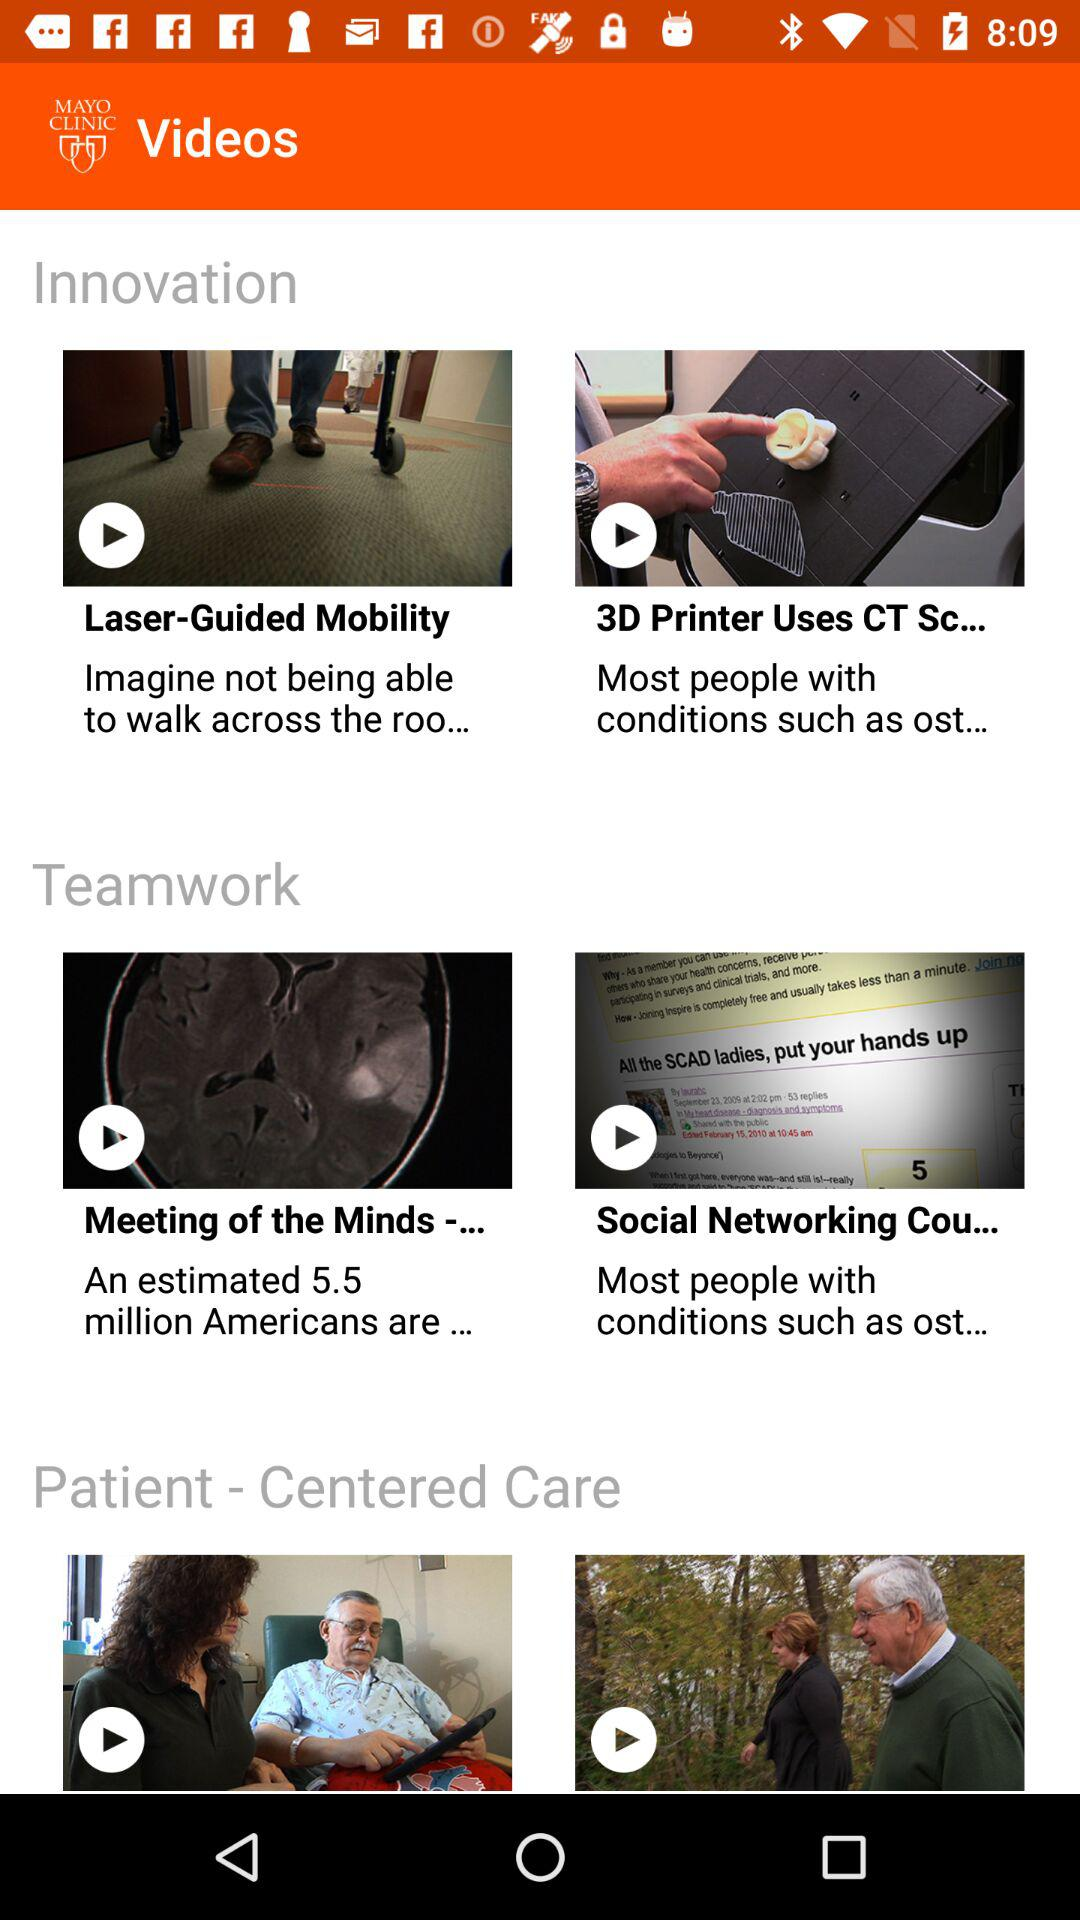How many videos are in the Innovation section?
Answer the question using a single word or phrase. 2 